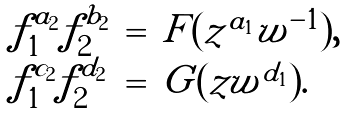Convert formula to latex. <formula><loc_0><loc_0><loc_500><loc_500>\begin{array} { l l l } f _ { 1 } ^ { a _ { 2 } } f _ { 2 } ^ { b _ { 2 } } & = & F ( z ^ { a _ { 1 } } w ^ { - 1 } ) , \\ f _ { 1 } ^ { c _ { 2 } } f _ { 2 } ^ { d _ { 2 } } & = & G ( z w ^ { d _ { 1 } } ) . \end{array}</formula> 